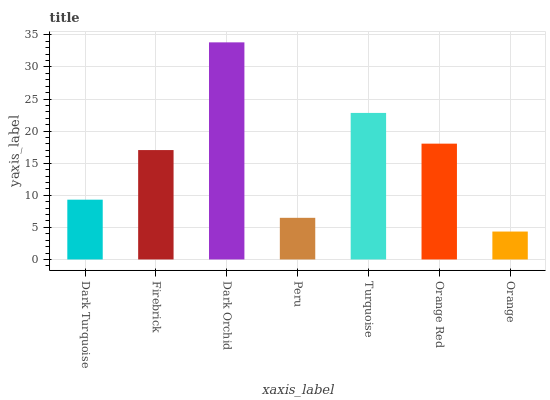Is Firebrick the minimum?
Answer yes or no. No. Is Firebrick the maximum?
Answer yes or no. No. Is Firebrick greater than Dark Turquoise?
Answer yes or no. Yes. Is Dark Turquoise less than Firebrick?
Answer yes or no. Yes. Is Dark Turquoise greater than Firebrick?
Answer yes or no. No. Is Firebrick less than Dark Turquoise?
Answer yes or no. No. Is Firebrick the high median?
Answer yes or no. Yes. Is Firebrick the low median?
Answer yes or no. Yes. Is Turquoise the high median?
Answer yes or no. No. Is Dark Turquoise the low median?
Answer yes or no. No. 